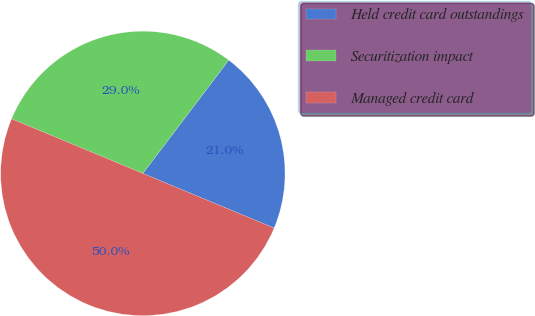Convert chart to OTSL. <chart><loc_0><loc_0><loc_500><loc_500><pie_chart><fcel>Held credit card outstandings<fcel>Securitization impact<fcel>Managed credit card<nl><fcel>20.95%<fcel>29.05%<fcel>50.0%<nl></chart> 